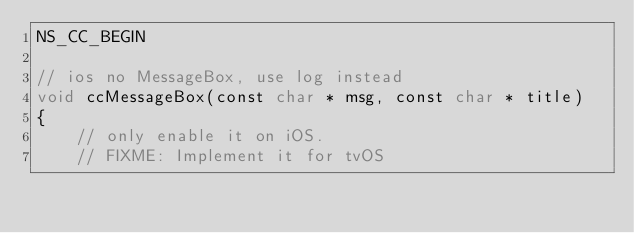Convert code to text. <code><loc_0><loc_0><loc_500><loc_500><_ObjectiveC_>NS_CC_BEGIN

// ios no MessageBox, use log instead
void ccMessageBox(const char * msg, const char * title)
{
    // only enable it on iOS.
    // FIXME: Implement it for tvOS</code> 